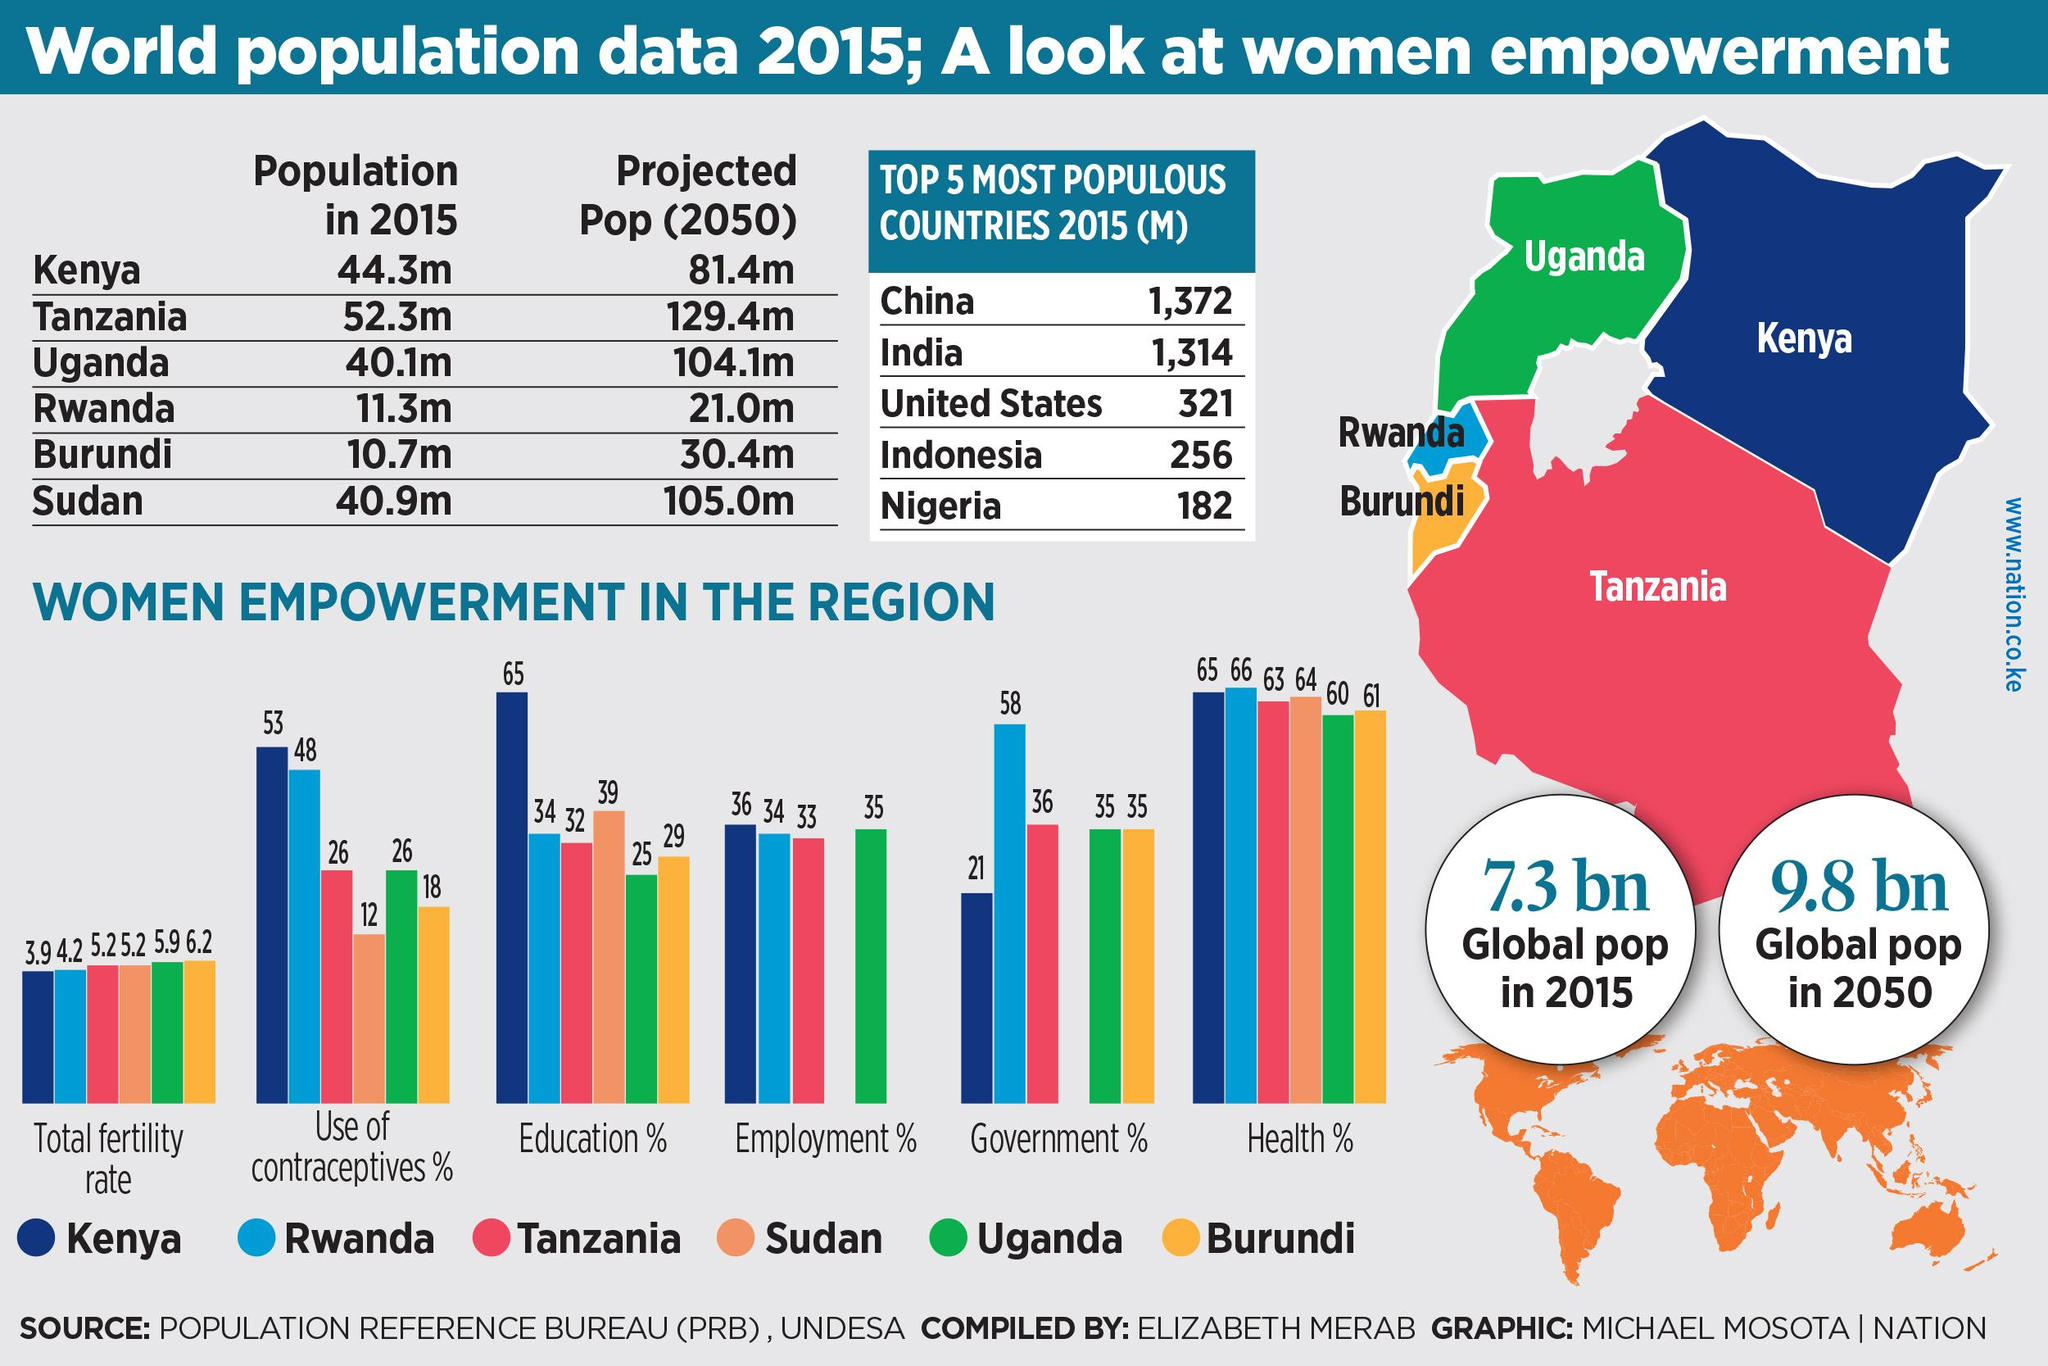Identify some key points in this picture. The percentage of women empowerment in the employment sectors of Uganda and Kenya taken together is 71%. In the past, the color blue was used to represent Kenya. However, it is no longer the case and the color green, yellow, and orange are now used instead. In 2015, the population of Kenya was projected to be 37.1 million. The total fertility rate in Kenya and Rwanda, taken together, is 8.1%. In Tanzania and Kenya, the percentage of women in the government sector is 57%. 